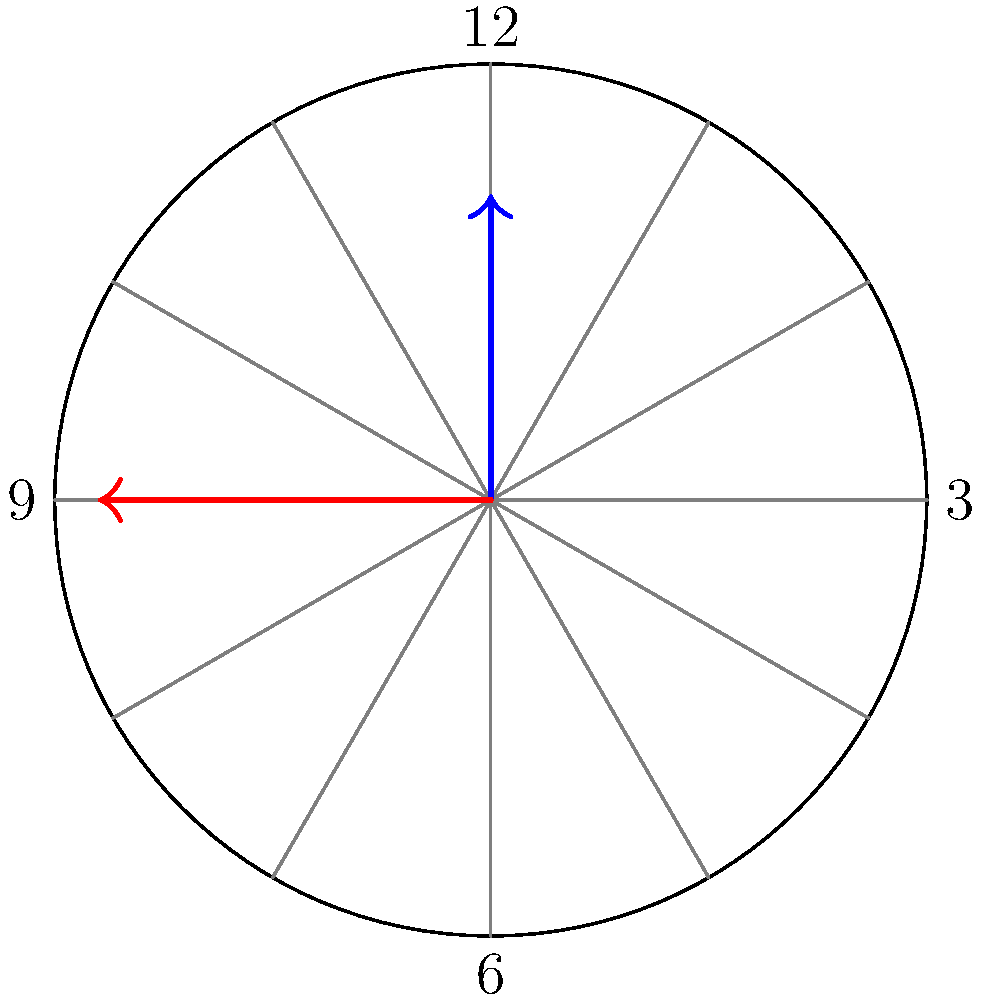As you're preparing for a clock-reading activity with your kindergarten students, you notice the clock in your classroom shows 3:30. If you were to estimate the angle between the hour and minute hands, which of these angles would be closest: 45°, 90°, or 135°? Let's approach this step-by-step:

1) First, recall that a full rotation of the clock (360°) is divided into 12 hours.
   So, each hour mark represents $\frac{360°}{12} = 30°$.

2) At 3:30, the hour hand will be halfway between 3 and 4.
   - 3 o'clock position: $3 \times 30° = 90°$
   - Halfway to 4: $90° + 15° = 105°$

3) The minute hand at 30 minutes (half past) will be at 6, which is at 180°.

4) To find the angle between the hands, subtract:
   $180° - 105° = 75°$

5) Now, compare 75° to the given options: 45°, 90°, and 135°.
   The closest value is 90°.

This estimation method is perfect for introducing young students to clock reading and basic angle concepts in a visual, hands-on way.
Answer: 90° 